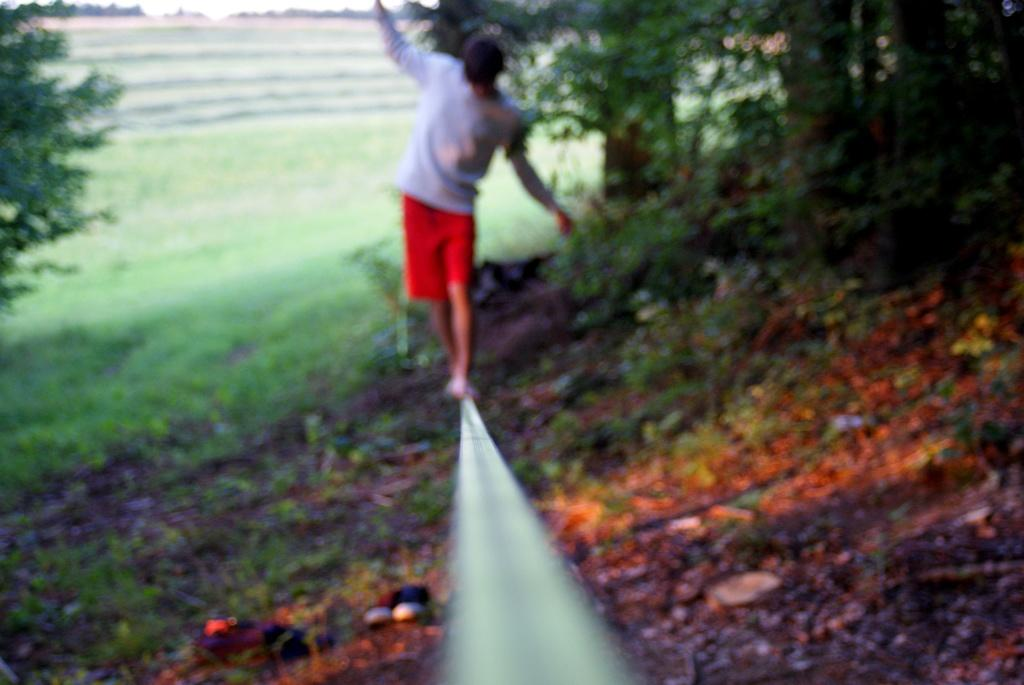What is the man in the image doing? The man is walking on a metal rod in the image. What can be seen in the background of the image? There are trees and grass visible in the background of the image. What type of crown is the man wearing while walking on the metal rod? There is no crown present in the image; the man is not wearing any headgear. 